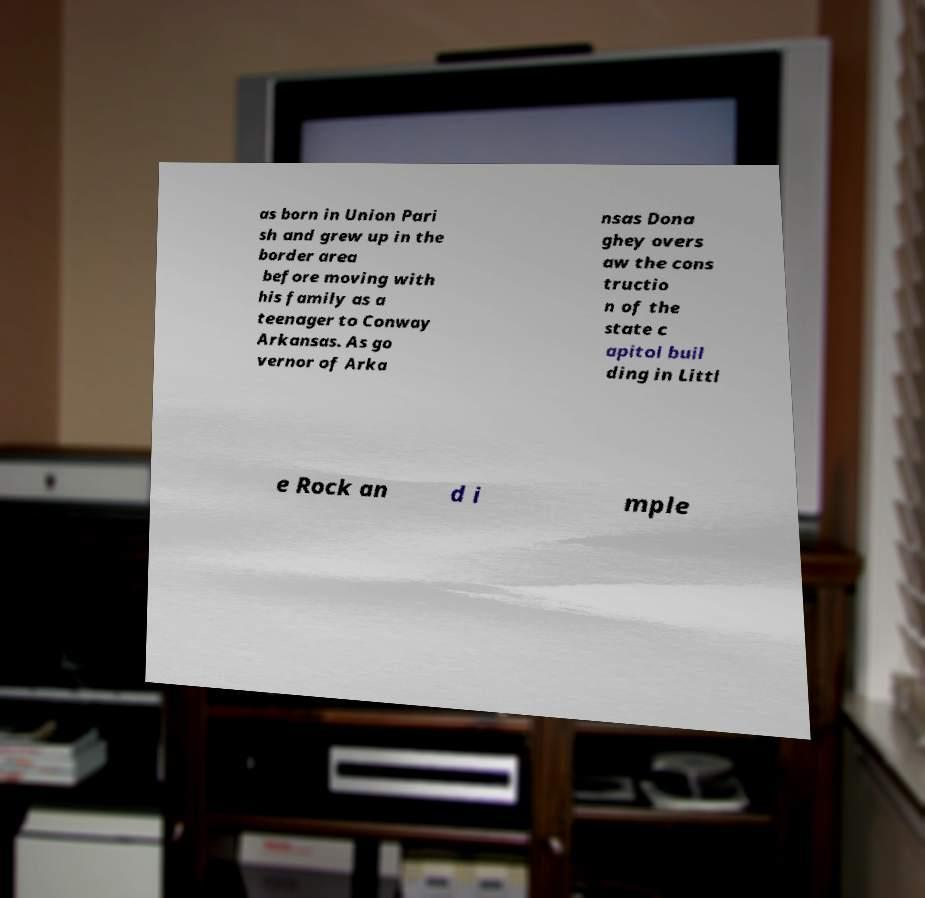Could you extract and type out the text from this image? as born in Union Pari sh and grew up in the border area before moving with his family as a teenager to Conway Arkansas. As go vernor of Arka nsas Dona ghey overs aw the cons tructio n of the state c apitol buil ding in Littl e Rock an d i mple 